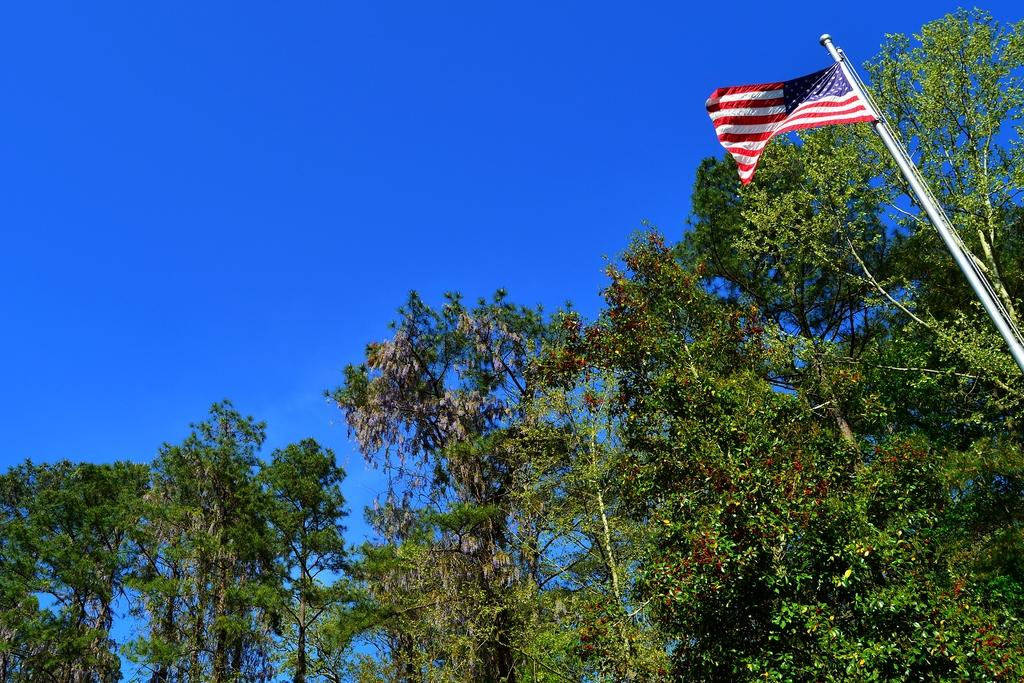What type of vegetation is at the bottom of the picture? There are trees at the bottom of the picture. What can be seen on the right side of the picture? There is a flag pole on the right side of the picture. What colors are present on the flag? The flag has white, red, and blue colors. What is visible at the top of the picture? The sky is visible at the top of the picture. What is the color of the sky? The color of the sky is blue. Where is the crate located in the image? There is no crate present in the image. What type of soap is used to clean the flag in the image? There is no soap or cleaning activity depicted in the image; it simply shows a flag on a pole. 